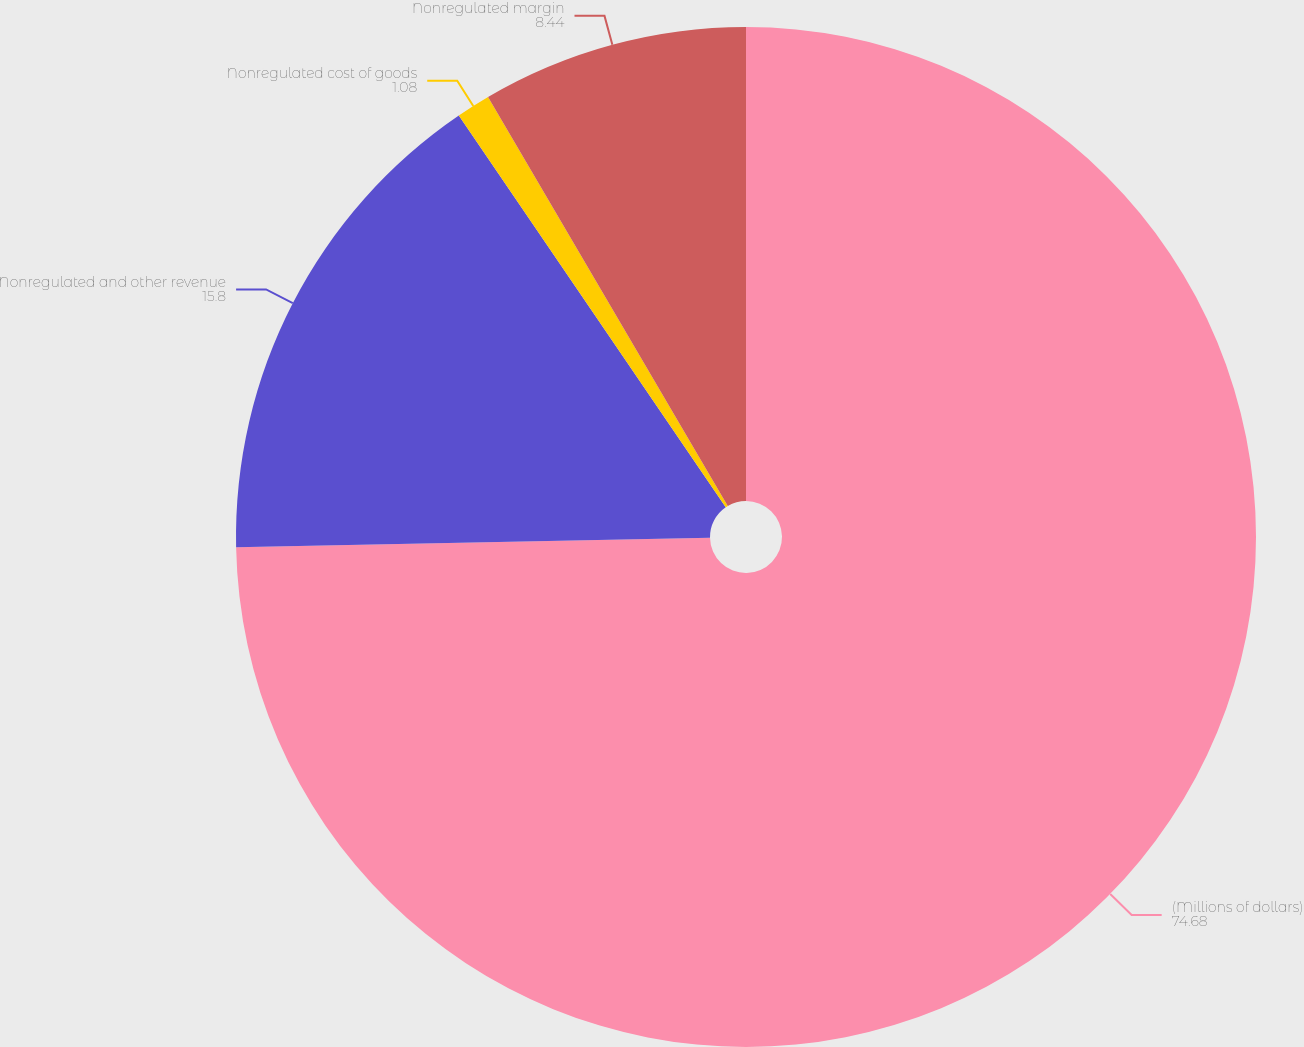Convert chart. <chart><loc_0><loc_0><loc_500><loc_500><pie_chart><fcel>(Millions of dollars)<fcel>Nonregulated and other revenue<fcel>Nonregulated cost of goods<fcel>Nonregulated margin<nl><fcel>74.68%<fcel>15.8%<fcel>1.08%<fcel>8.44%<nl></chart> 